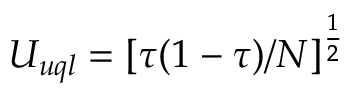Convert formula to latex. <formula><loc_0><loc_0><loc_500><loc_500>U _ { u q l } = [ \tau ( 1 - \tau ) / N ] ^ { \frac { 1 } { 2 } }</formula> 